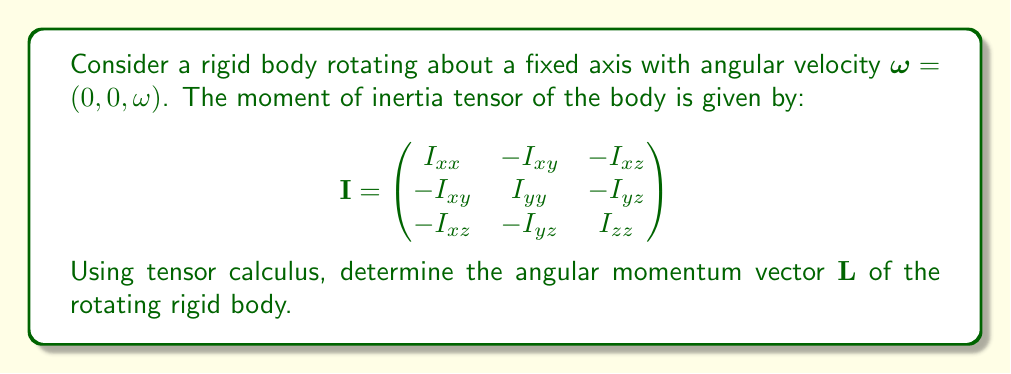Solve this math problem. To solve this problem, we'll follow these steps:

1) The angular momentum $\mathbf{L}$ of a rotating rigid body is given by the tensor equation:

   $$\mathbf{L} = \mathbf{I} \cdot \boldsymbol{\omega}$$

2) We need to perform the matrix multiplication of the moment of inertia tensor $\mathbf{I}$ with the angular velocity vector $\boldsymbol{\omega}$:

   $$\begin{pmatrix}
   I_{xx} & -I_{xy} & -I_{xz} \\
   -I_{xy} & I_{yy} & -I_{yz} \\
   -I_{xz} & -I_{yz} & I_{zz}
   \end{pmatrix} \cdot \begin{pmatrix}
   0 \\
   0 \\
   \omega
   \end{pmatrix}$$

3) Performing the multiplication:

   $$\mathbf{L} = \begin{pmatrix}
   -I_{xz}\omega \\
   -I_{yz}\omega \\
   I_{zz}\omega
   \end{pmatrix}$$

4) Therefore, the components of the angular momentum vector are:

   $$L_x = -I_{xz}\omega$$
   $$L_y = -I_{yz}\omega$$
   $$L_z = I_{zz}\omega$$

5) We can write the final angular momentum vector as:

   $$\mathbf{L} = (-I_{xz}\omega, -I_{yz}\omega, I_{zz}\omega)$$

This result shows how the off-diagonal elements of the moment of inertia tensor contribute to the x and y components of the angular momentum, even though the rotation is about the z-axis.
Answer: $\mathbf{L} = (-I_{xz}\omega, -I_{yz}\omega, I_{zz}\omega)$ 